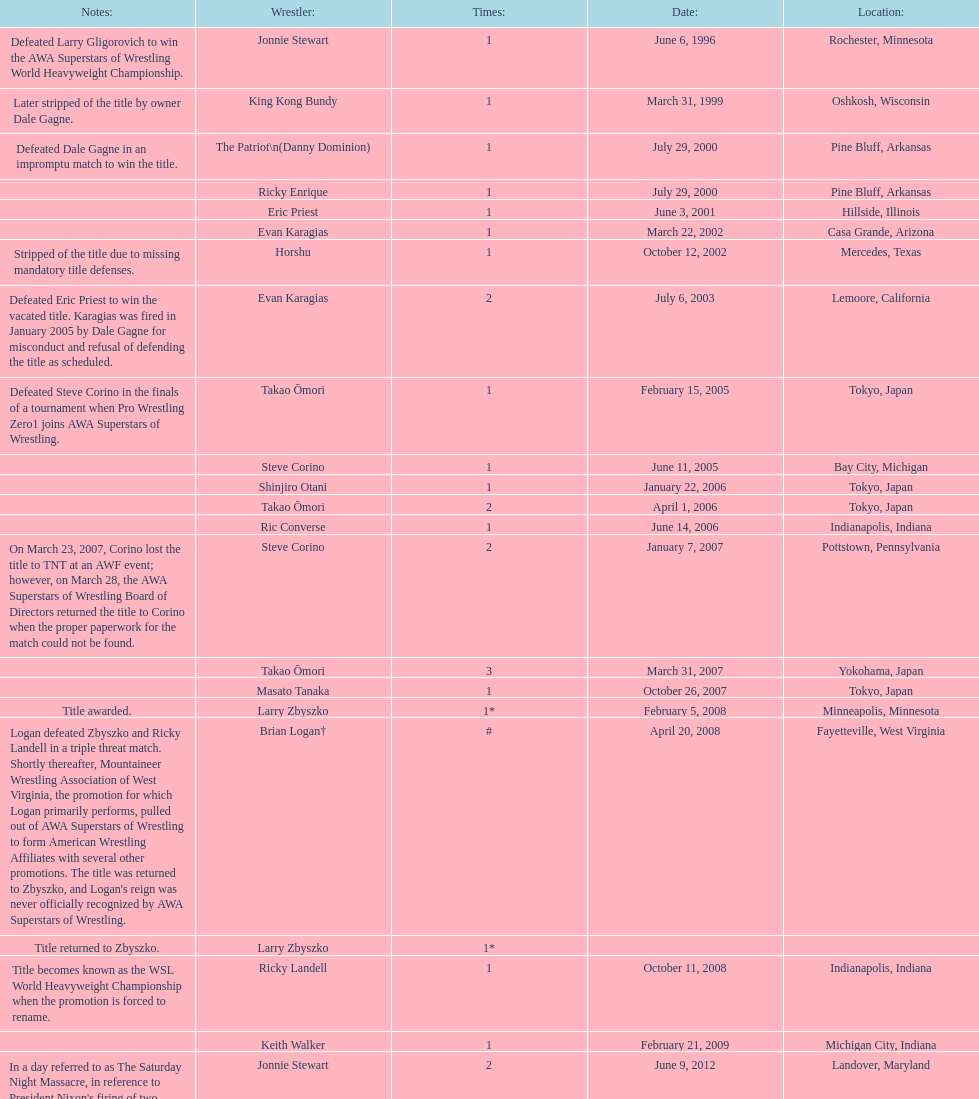How many different men held the wsl title before horshu won his first wsl title? 6. 